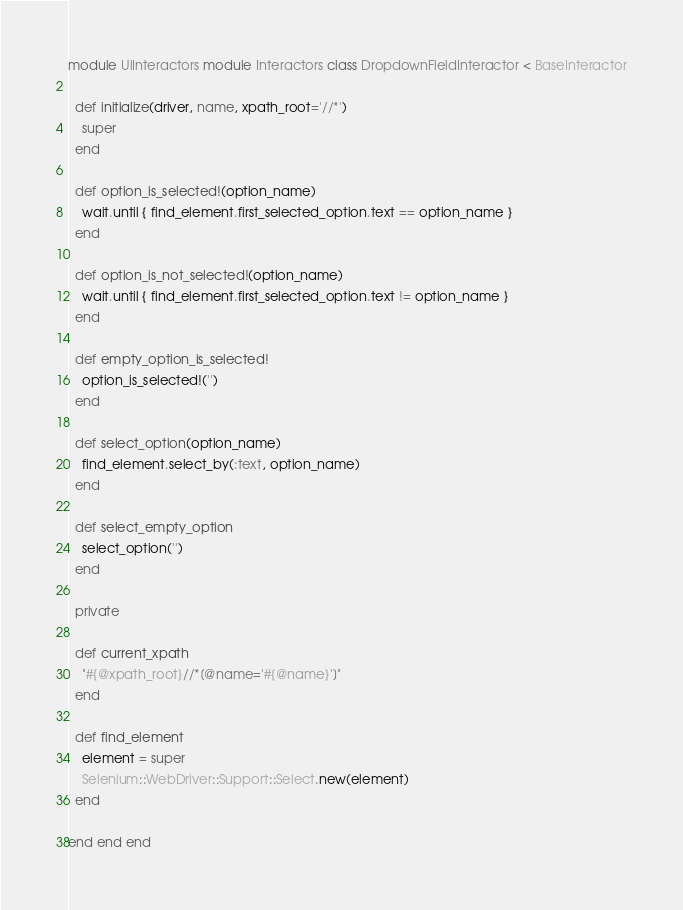<code> <loc_0><loc_0><loc_500><loc_500><_Ruby_>module UiInteractors module Interactors class DropdownFieldInteractor < BaseInteractor

  def initialize(driver, name, xpath_root='//*')
    super
  end

  def option_is_selected!(option_name)
    wait.until { find_element.first_selected_option.text == option_name }
  end

  def option_is_not_selected!(option_name)
    wait.until { find_element.first_selected_option.text != option_name }
  end

  def empty_option_is_selected!
    option_is_selected!('')
  end

  def select_option(option_name)
    find_element.select_by(:text, option_name)
  end
  
  def select_empty_option
    select_option('')
  end

  private

  def current_xpath
    "#{@xpath_root}//*[@name='#{@name}']"
  end

  def find_element
    element = super
    Selenium::WebDriver::Support::Select.new(element)
  end

end end end
</code> 